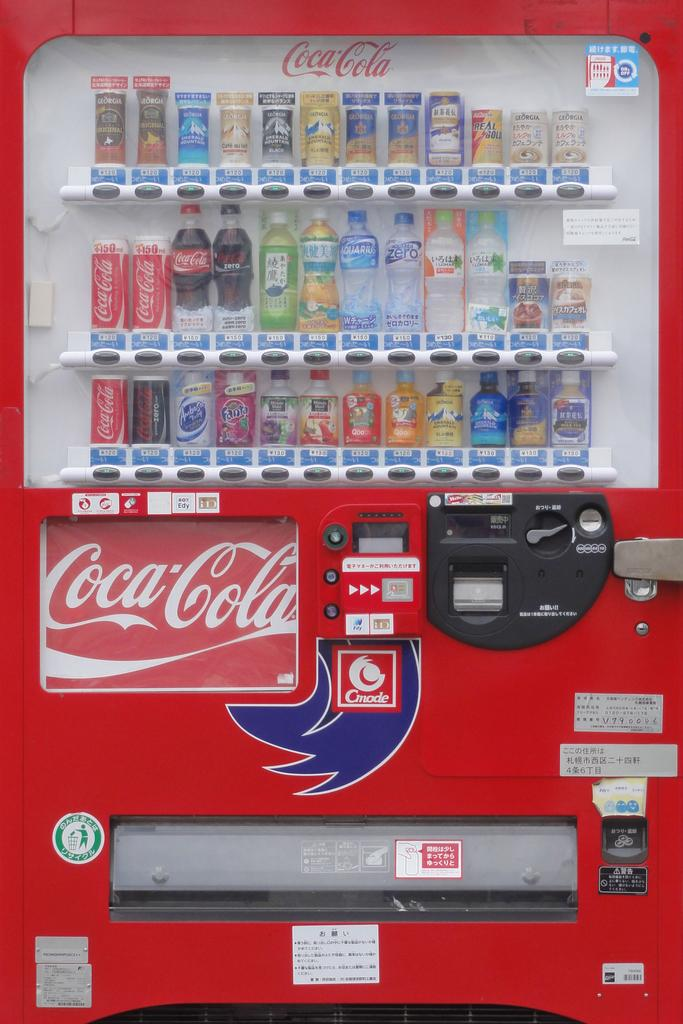What type of appliance is visible in the image? There is a fridge in the image. What is stored inside the fridge? There are multiple bottles in the fridge. Is there any additional decoration or labeling on the fridge? Yes, the fridge has a sticker. What brand or company is represented by the sticker on the fridge? The sticker on the fridge is a Coca Cola sticker. Can you hear the cow mooing in the image? There is no cow present in the image, so it is not possible to hear a cow mooing. 